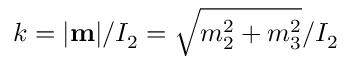Convert formula to latex. <formula><loc_0><loc_0><loc_500><loc_500>k = | { m } | / I _ { 2 } = \sqrt { m _ { 2 } ^ { 2 } + m _ { 3 } ^ { 2 } } / I _ { 2 }</formula> 